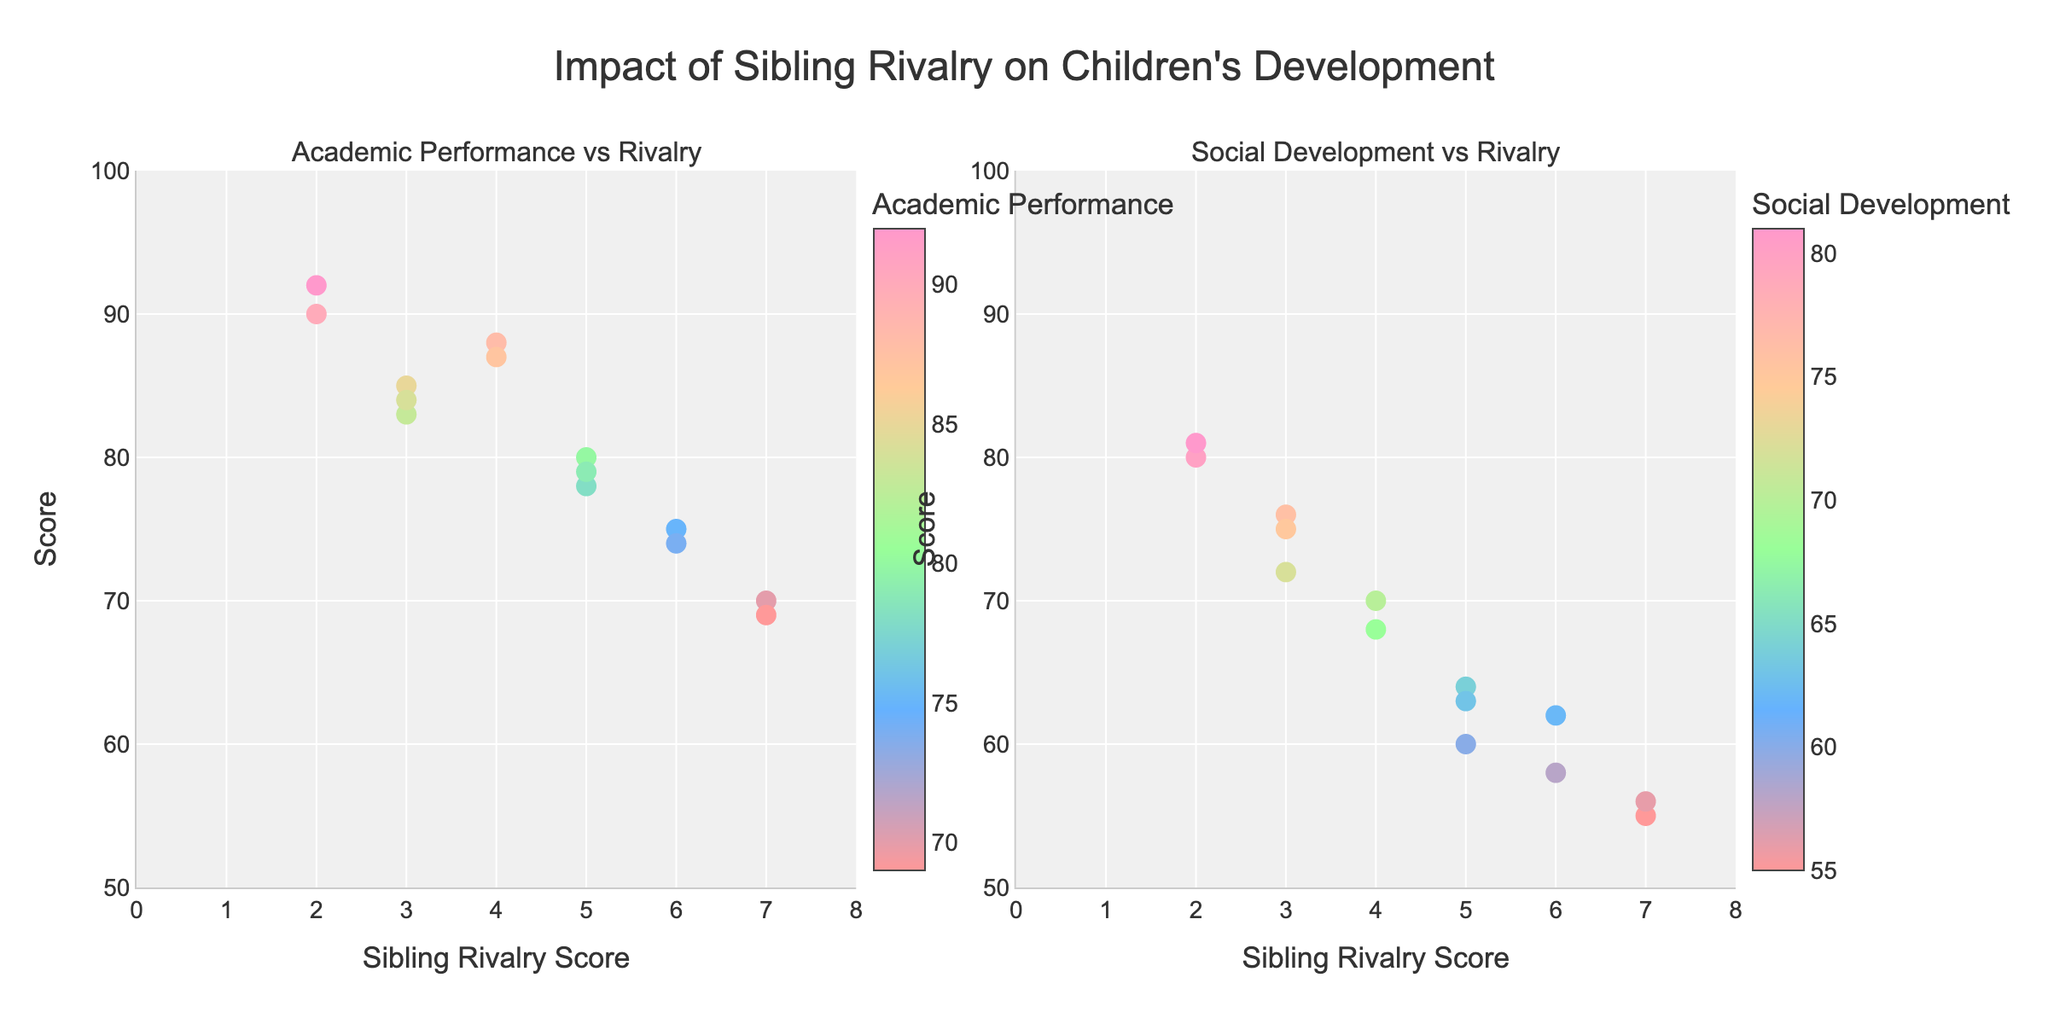what is the title of the figure? The title is located at the top of the figure and reads, "Impact of Sibling Rivalry on Children's Development," indicating the study's subject.
Answer: "Impact of Sibling Rivalry on Children's Development" What are the x and y axes representing in the Academic Performance subplot? The x-axis represents the Sibling Rivalry Score with a range from 0 to 8, and the y-axis represents the Academic Performance Score with a range from 50 to 100. This shows how rivalry scores correlate with academic scores.
Answer: Sibling Rivalry Score and Academic Performance Score Which child has the highest Academic Performance Score, and what is that score? By examining the hover information, we can see that Lily has the highest Academic Performance Score of 92.
Answer: Lily, 92 Which data point has the highest Social Development Score, and what is that score? By examining the subplot for Social Development and checking the hover information, we find that Lily has the highest Social Development Score of 81.
Answer: Lily, 81 Is there a child with a high Sibling Rivalry Score but low Academic Performance? By looking at the Academic Performance subplot, we see that Michael has a high Sibling Rivalry Score (7) and a low Academic Performance Score (70).
Answer: Michael, 7 rivalry score, 70 performance Compare the Social Development Scores of Alice and Olivia. Which child has a higher score? The hover information shows Alice has a Social Development Score of 72, while Olivia has 76. So, Olivia has a higher score.
Answer: Olivia What is the average Social Development Score for children with a Sibling Rivalry Score of 5? Children with a Sibling Rivalry Score of 5 are John, James, and Lucas. Their Social Development Scores are 60, 64, and 63 respectively. The average is calculated as (60+64+63)/3 = 62.33.
Answer: 62.33 Do children with lower Sibling Rivalry Scores generally have better Academic Performance? Observing the subplot for Academic Performance, children like Emily (2, 90), and Lily (2, 92) with low rivalry scores tend to have higher academic scores compared to those like Michael (7, 70) with higher rivalry scores. Thus, a trend of lower rivalry correlating with better performance can be inferred.
Answer: Yes What is the lowest Social Development Score, and which child has it? By hovering over the points in the Social Development subplot, it is found that Michael has the lowest Social Development Score of 55.
Answer: Michael, 55 